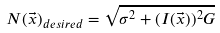<formula> <loc_0><loc_0><loc_500><loc_500>N ( \vec { x } ) _ { d e s i r e d } = \sqrt { \sigma ^ { 2 } + ( I ( \vec { x } ) ) ^ { 2 } G }</formula> 